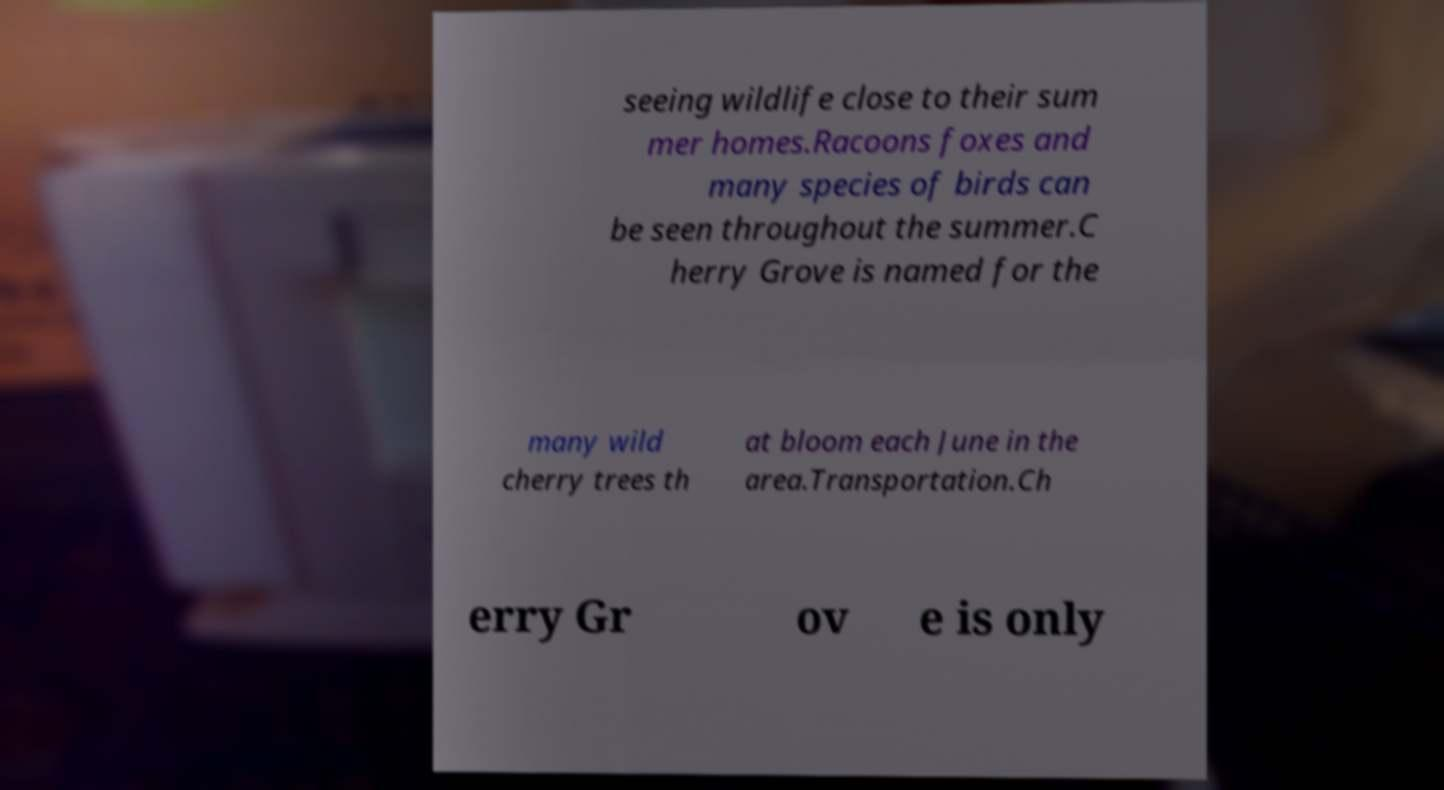Can you read and provide the text displayed in the image?This photo seems to have some interesting text. Can you extract and type it out for me? seeing wildlife close to their sum mer homes.Racoons foxes and many species of birds can be seen throughout the summer.C herry Grove is named for the many wild cherry trees th at bloom each June in the area.Transportation.Ch erry Gr ov e is only 